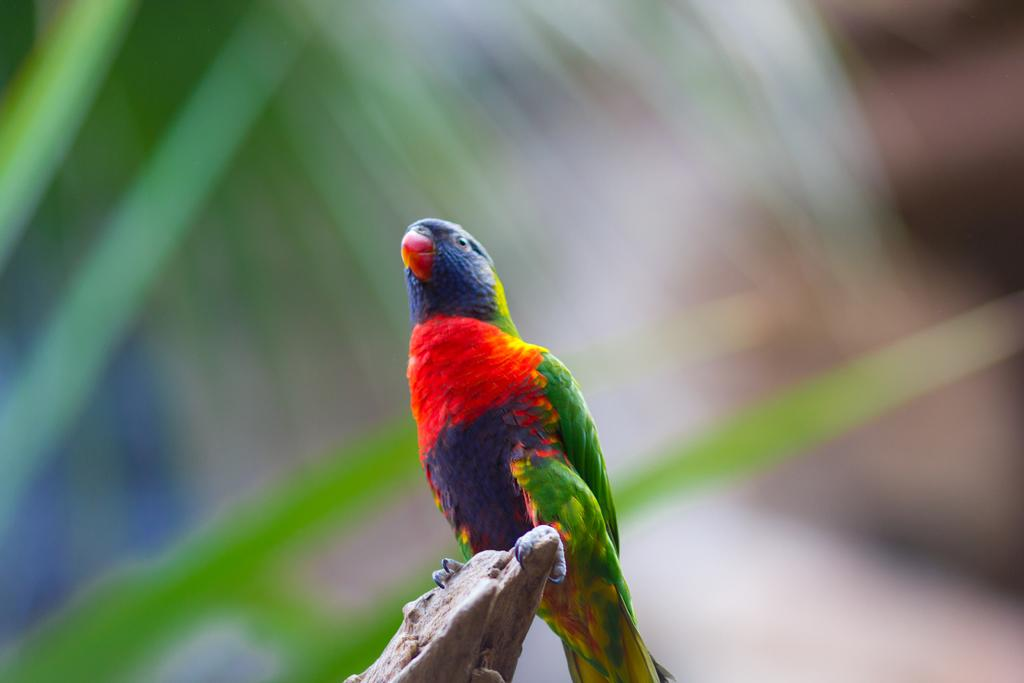What type of animal is in the image? There is a bird in the image. Where is the bird located? The bird is on an object. Can you describe the background of the image? The background of the image is blurred. Is the bird playing a guitar in the image? There is no guitar present in the image, and the bird is not depicted playing any musical instrument. 